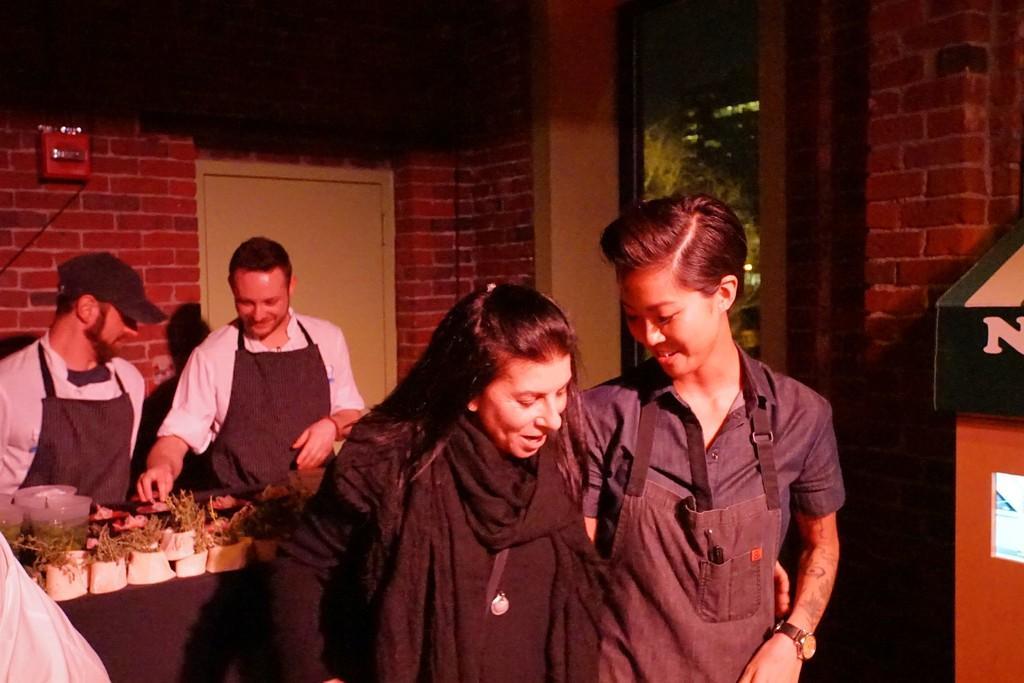How would you summarize this image in a sentence or two? As we can see in the image there is a brick wall, mirror, door, few people here and there and a table. On table there is a black color cloth and plants. 